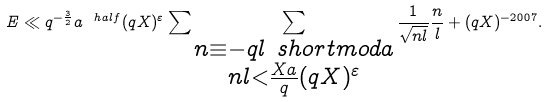Convert formula to latex. <formula><loc_0><loc_0><loc_500><loc_500>E \ll q ^ { - \frac { 3 } { 2 } } a ^ { \ h a l f } ( q X ) ^ { \varepsilon } \sum \sum _ { \substack { n \equiv - q l \ s h o r t m o d { a } \\ n l < \frac { X a } { q } ( q X ) ^ { \varepsilon } } } \frac { 1 } { \sqrt { n l } } \frac { n } { l } + ( q X ) ^ { - 2 0 0 7 } .</formula> 